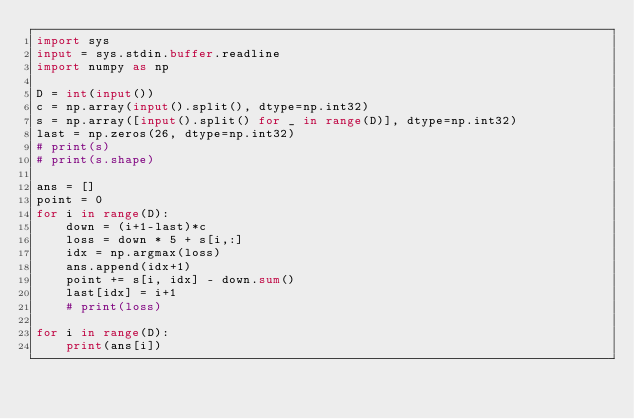Convert code to text. <code><loc_0><loc_0><loc_500><loc_500><_Python_>import sys
input = sys.stdin.buffer.readline
import numpy as np

D = int(input())
c = np.array(input().split(), dtype=np.int32)
s = np.array([input().split() for _ in range(D)], dtype=np.int32)
last = np.zeros(26, dtype=np.int32)
# print(s)
# print(s.shape)

ans = []
point = 0
for i in range(D):
    down = (i+1-last)*c
    loss = down * 5 + s[i,:]
    idx = np.argmax(loss)
    ans.append(idx+1)
    point += s[i, idx] - down.sum()
    last[idx] = i+1
    # print(loss)

for i in range(D):
    print(ans[i])</code> 